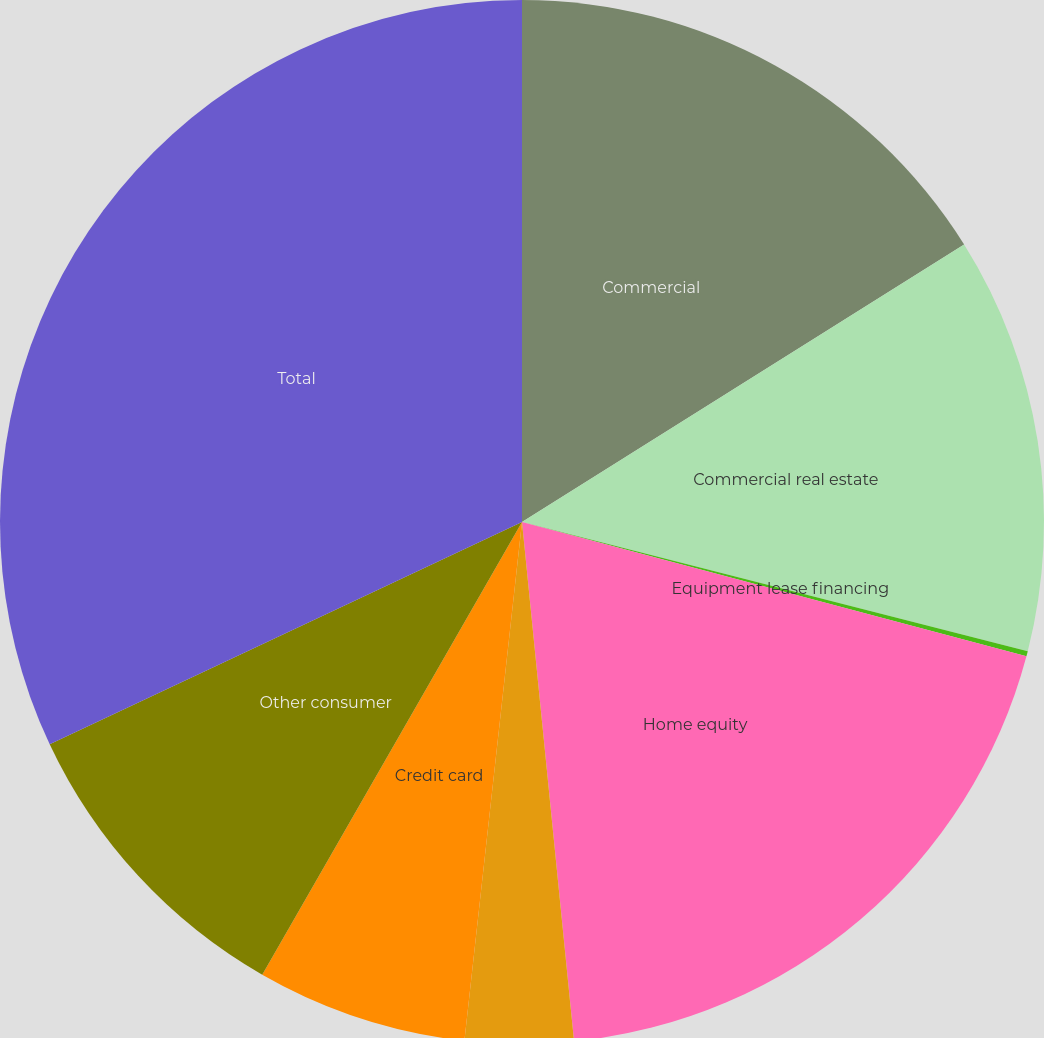Convert chart to OTSL. <chart><loc_0><loc_0><loc_500><loc_500><pie_chart><fcel>Commercial<fcel>Commercial real estate<fcel>Equipment lease financing<fcel>Home equity<fcel>Residential real estate<fcel>Credit card<fcel>Other consumer<fcel>Total<nl><fcel>16.08%<fcel>12.9%<fcel>0.16%<fcel>19.27%<fcel>3.35%<fcel>6.53%<fcel>9.71%<fcel>32.0%<nl></chart> 